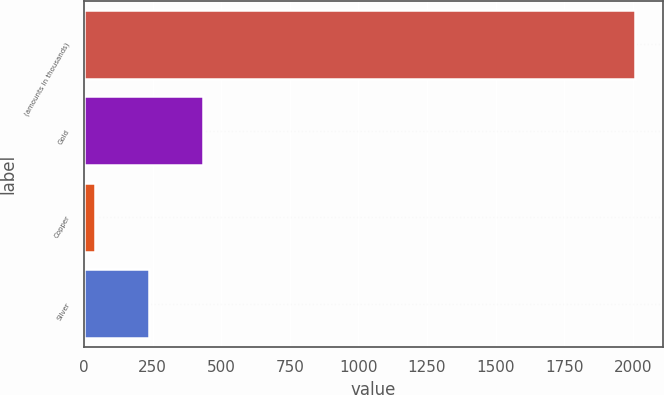<chart> <loc_0><loc_0><loc_500><loc_500><bar_chart><fcel>(amounts in thousands)<fcel>Gold<fcel>Copper<fcel>Silver<nl><fcel>2010<fcel>434.8<fcel>41<fcel>237.9<nl></chart> 